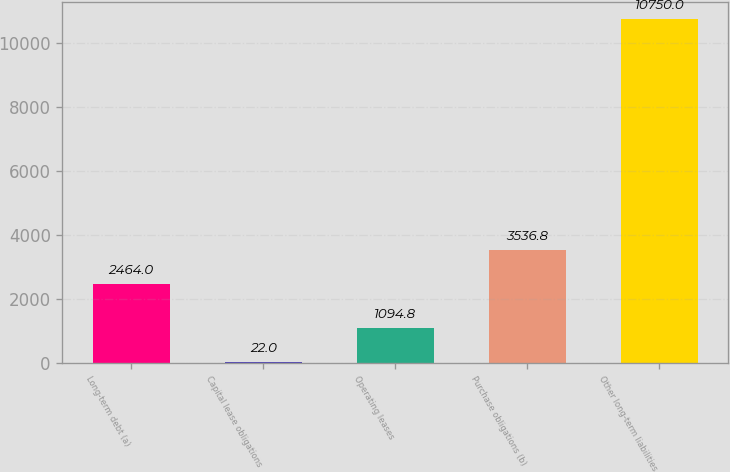Convert chart to OTSL. <chart><loc_0><loc_0><loc_500><loc_500><bar_chart><fcel>Long-term debt (a)<fcel>Capital lease obligations<fcel>Operating leases<fcel>Purchase obligations (b)<fcel>Other long-term liabilities<nl><fcel>2464<fcel>22<fcel>1094.8<fcel>3536.8<fcel>10750<nl></chart> 